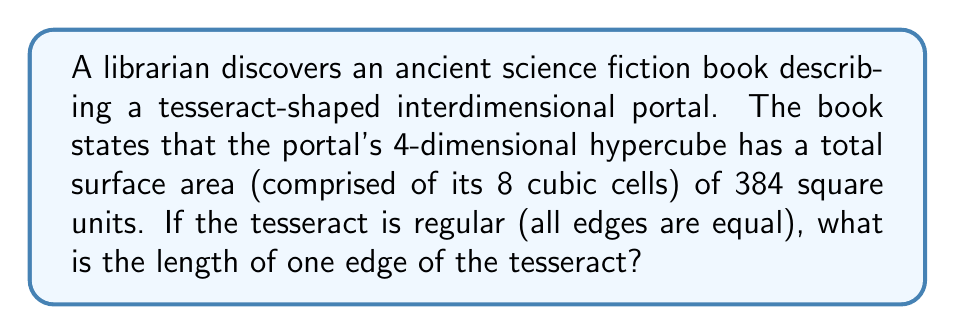Teach me how to tackle this problem. Let's approach this step-by-step:

1) First, recall that a tesseract is a 4-dimensional hypercube with 8 cubic cells as its "surface".

2) For a regular tesseract, if we denote the length of one edge as $a$, then each cubic cell has:
   - Edge length: $a$
   - Face area: $a^2$
   - Surface area: $6a^2$
   - Volume: $a^3$

3) The total surface area of the tesseract is the sum of the surface areas of its 8 cubic cells:

   $$ \text{Total Surface Area} = 8 \times 6a^2 = 48a^2 $$

4) We're given that this total surface area is 384 square units. So we can set up the equation:

   $$ 48a^2 = 384 $$

5) Solving for $a$:

   $$ a^2 = \frac{384}{48} = 8 $$
   $$ a = \sqrt{8} = 2\sqrt{2} $$

Therefore, the length of one edge of the tesseract is $2\sqrt{2}$ units.
Answer: $2\sqrt{2}$ units 